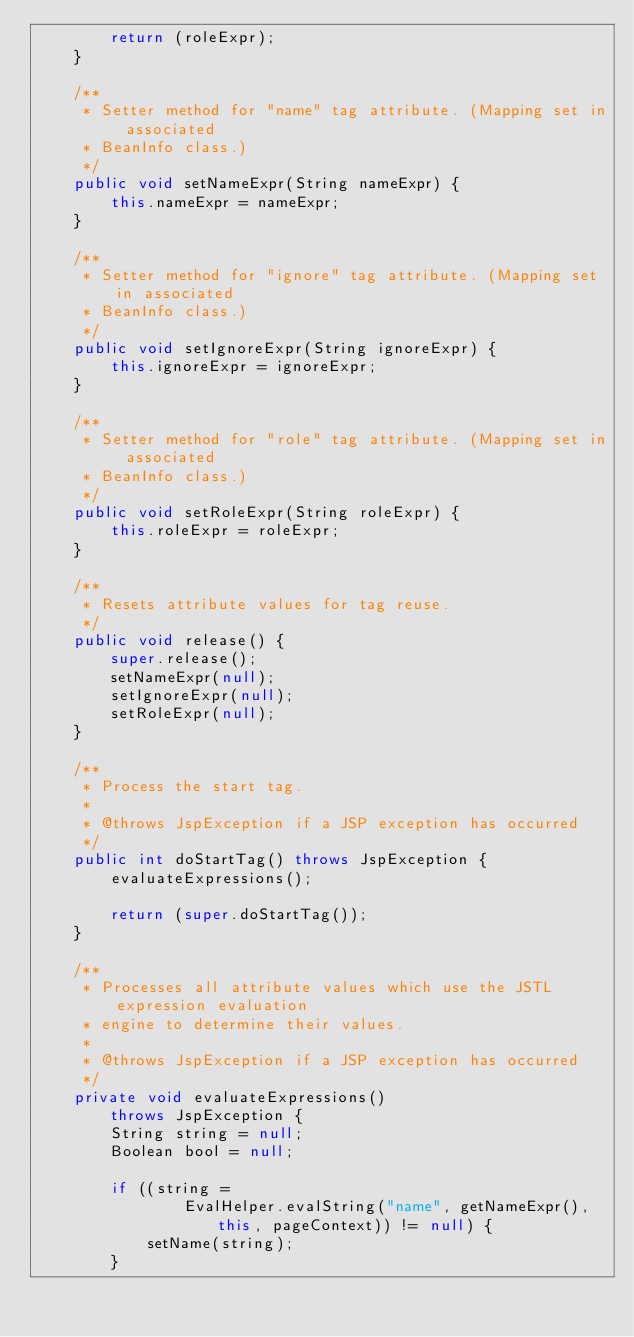Convert code to text. <code><loc_0><loc_0><loc_500><loc_500><_Java_>        return (roleExpr);
    }

    /**
     * Setter method for "name" tag attribute. (Mapping set in associated
     * BeanInfo class.)
     */
    public void setNameExpr(String nameExpr) {
        this.nameExpr = nameExpr;
    }

    /**
     * Setter method for "ignore" tag attribute. (Mapping set in associated
     * BeanInfo class.)
     */
    public void setIgnoreExpr(String ignoreExpr) {
        this.ignoreExpr = ignoreExpr;
    }

    /**
     * Setter method for "role" tag attribute. (Mapping set in associated
     * BeanInfo class.)
     */
    public void setRoleExpr(String roleExpr) {
        this.roleExpr = roleExpr;
    }

    /**
     * Resets attribute values for tag reuse.
     */
    public void release() {
        super.release();
        setNameExpr(null);
        setIgnoreExpr(null);
        setRoleExpr(null);
    }

    /**
     * Process the start tag.
     *
     * @throws JspException if a JSP exception has occurred
     */
    public int doStartTag() throws JspException {
        evaluateExpressions();

        return (super.doStartTag());
    }

    /**
     * Processes all attribute values which use the JSTL expression evaluation
     * engine to determine their values.
     *
     * @throws JspException if a JSP exception has occurred
     */
    private void evaluateExpressions()
        throws JspException {
        String string = null;
        Boolean bool = null;

        if ((string =
                EvalHelper.evalString("name", getNameExpr(), this, pageContext)) != null) {
            setName(string);
        }
</code> 